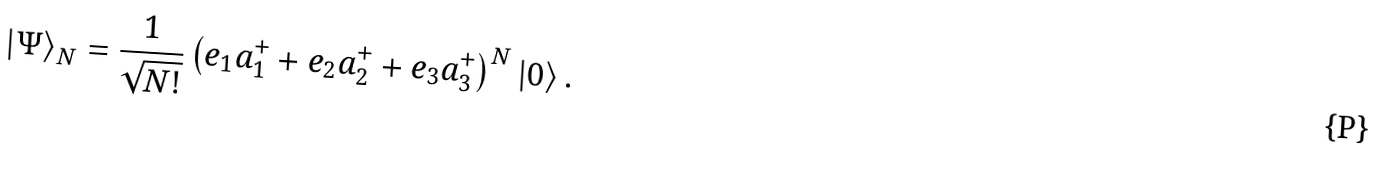Convert formula to latex. <formula><loc_0><loc_0><loc_500><loc_500>\left | { \Psi } \right \rangle _ { N } = \frac { 1 } { { \sqrt { N ! } } } \left ( { e _ { 1 } a _ { 1 } ^ { + } + e _ { 2 } a _ { 2 } ^ { + } + e _ { 3 } a _ { 3 } ^ { + } } \right ) ^ { N } \left | { 0 } \right \rangle .</formula> 